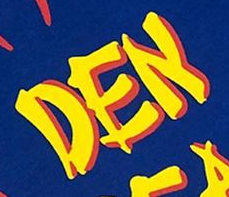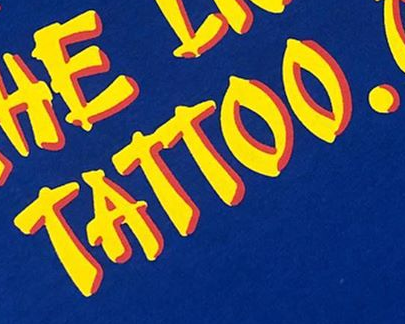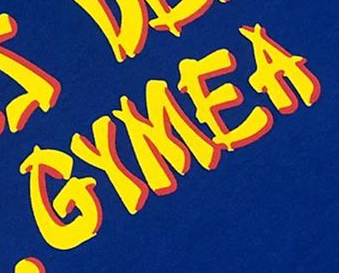What words can you see in these images in sequence, separated by a semicolon? DEN; TATTOO.; GYMEA 